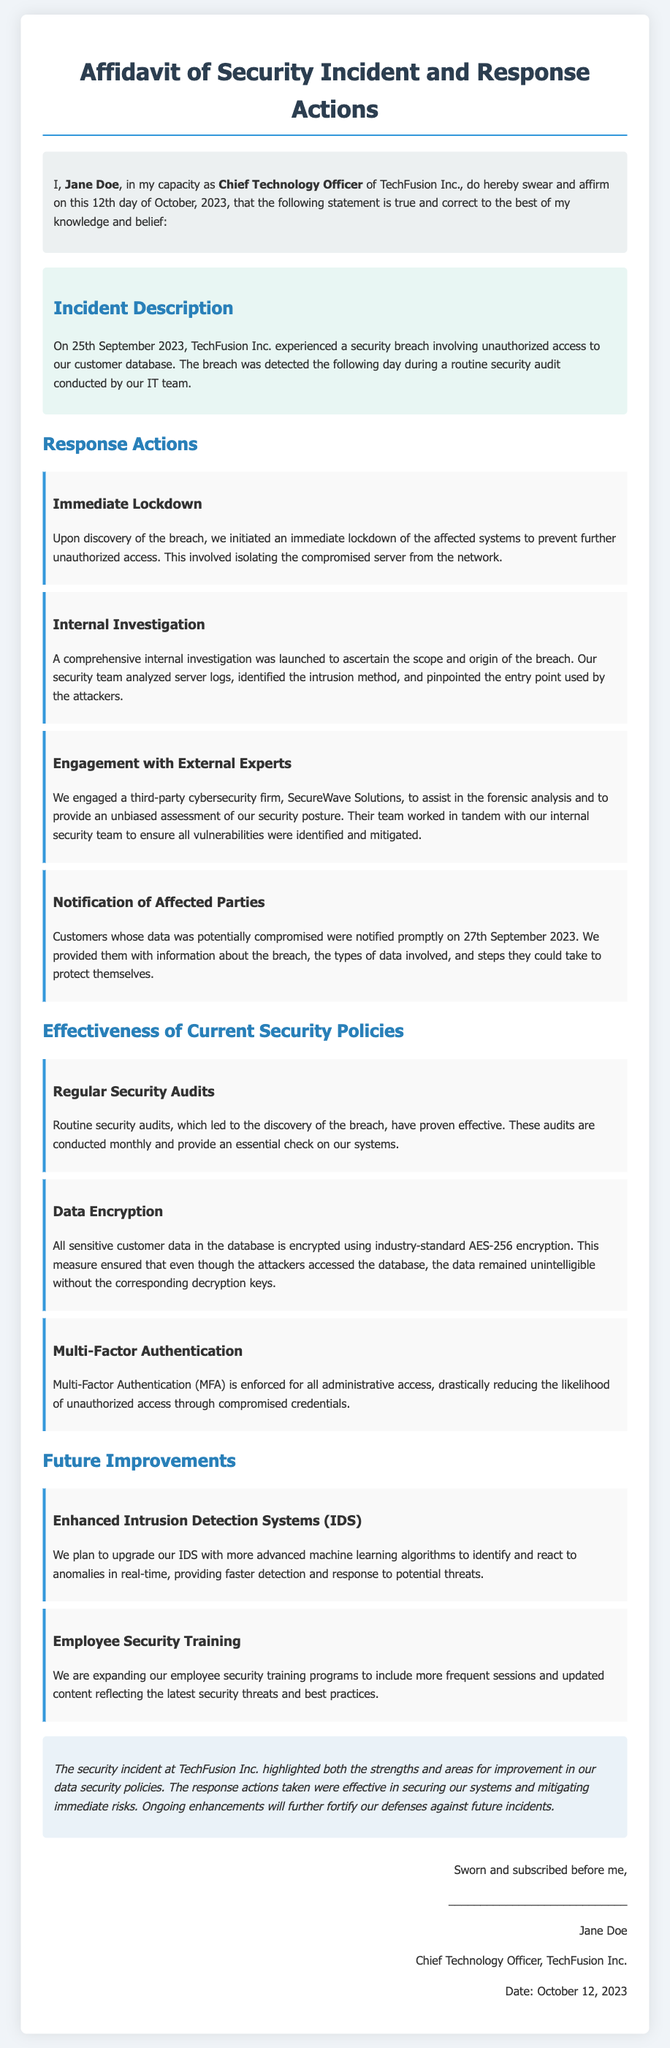What is the name of the deponent? The deponent's name is mentioned at the start of the affidavit: "I, Jane Doe".
Answer: Jane Doe When was the security breach detected? The document states that the breach was detected on "the following day" after it occurred on September 25, 2023. Therefore, it was detected on September 26, 2023.
Answer: September 26, 2023 Which company assisted in the forensic analysis? The affidavit mentions the engagement of a third-party firm for assistance, specifically "SecureWave Solutions".
Answer: SecureWave Solutions What type of encryption is used for customer data? The document indicates that the encryption used for sensitive customer data is "industry-standard AES-256 encryption".
Answer: AES-256 What is one measure taken to notify affected customers? The affidavit specifies that customers were "notified promptly on 27th September 2023".
Answer: Notified promptly on 27th September 2023 What is one future improvement mentioned in the document? The affidavit lists plans for "Enhanced Intrusion Detection Systems (IDS)" as a future improvement.
Answer: Enhanced Intrusion Detection Systems (IDS) Who is the Chief Technology Officer of TechFusion Inc.? The document states the title and name: "Jane Doe, Chief Technology Officer".
Answer: Jane Doe What date was the affidavit sworn? The specific date on which the affidavit was affirmed is noted as "October 12, 2023".
Answer: October 12, 2023 